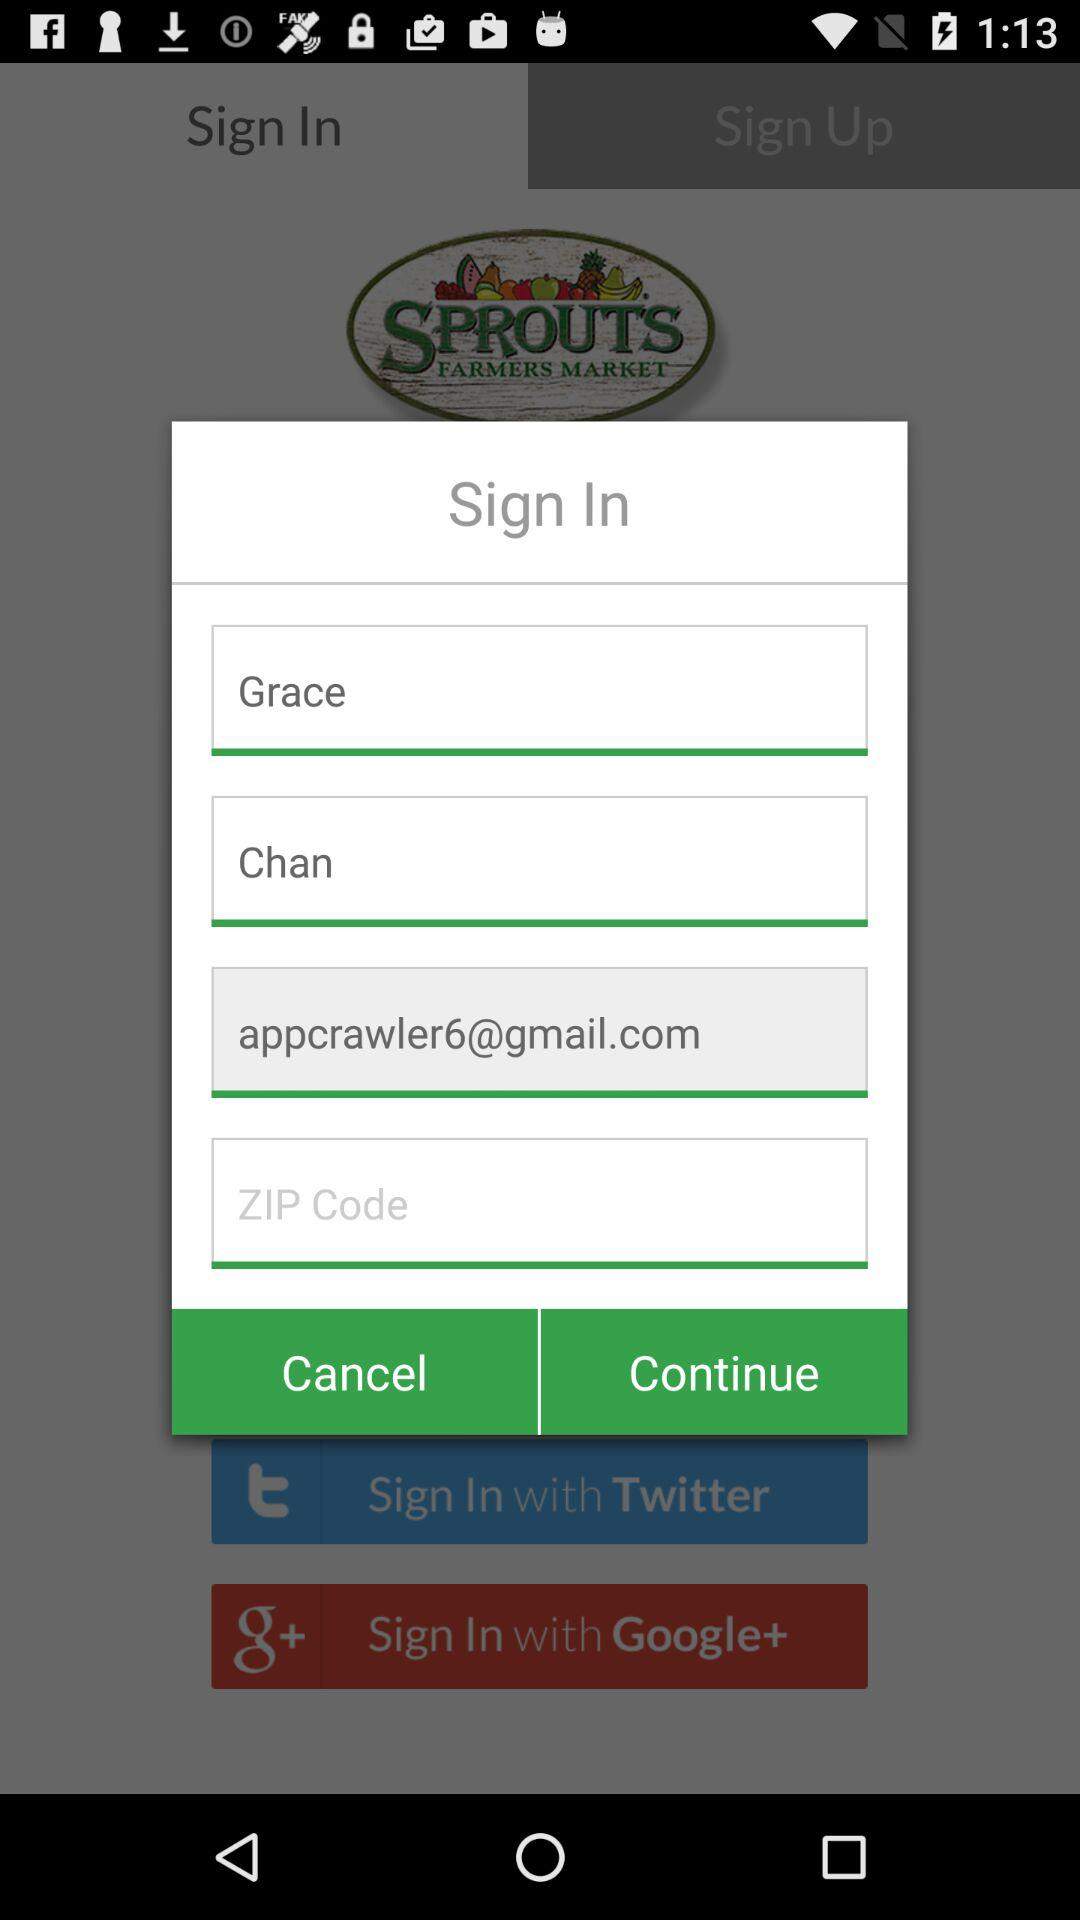What is the email address? The email address is appcrawler6@gmail.com. 